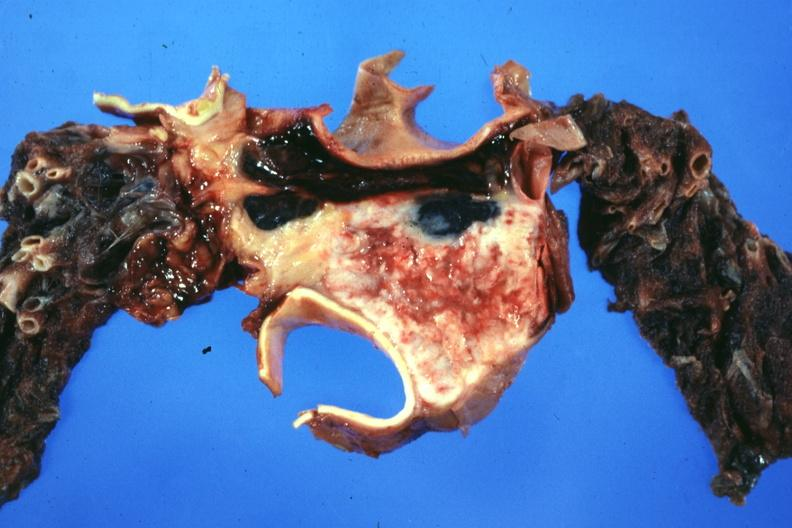does this image show section through mediastinal structure showing tumor about aorta and pulmonary arteries?
Answer the question using a single word or phrase. Yes 